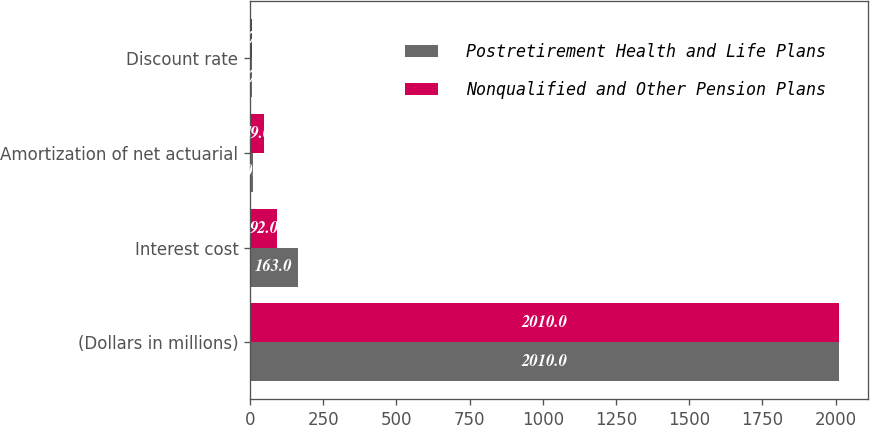Convert chart to OTSL. <chart><loc_0><loc_0><loc_500><loc_500><stacked_bar_chart><ecel><fcel>(Dollars in millions)<fcel>Interest cost<fcel>Amortization of net actuarial<fcel>Discount rate<nl><fcel>Postretirement Health and Life Plans<fcel>2010<fcel>163<fcel>10<fcel>5.75<nl><fcel>Nonqualified and Other Pension Plans<fcel>2010<fcel>92<fcel>49<fcel>5.75<nl></chart> 